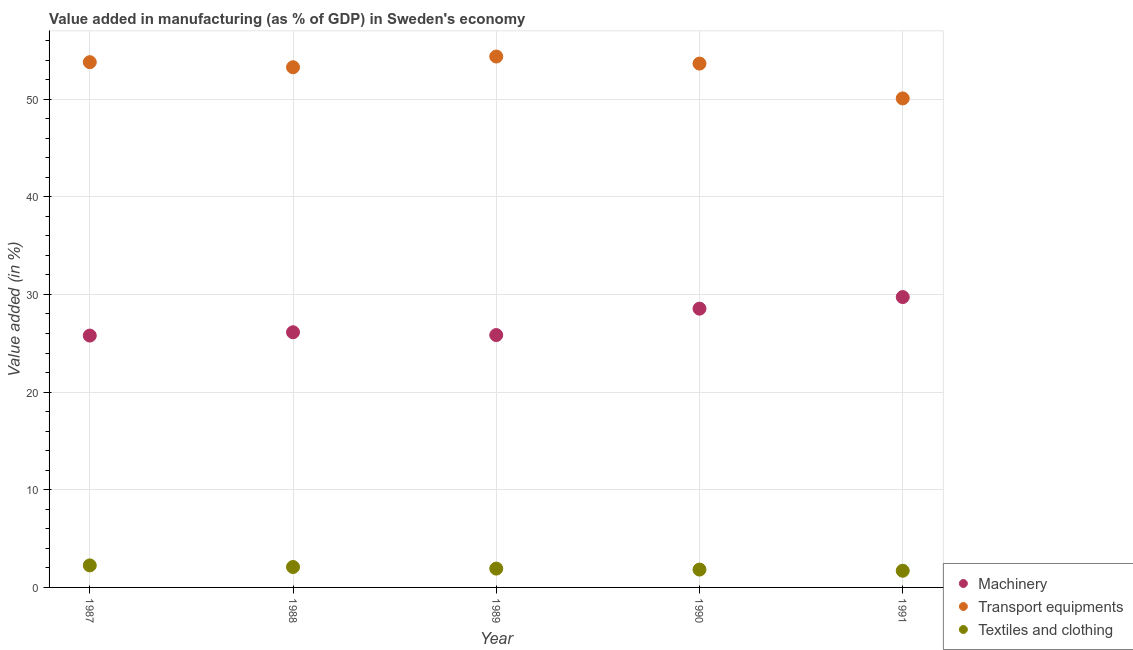What is the value added in manufacturing transport equipments in 1991?
Your answer should be very brief. 50.07. Across all years, what is the maximum value added in manufacturing textile and clothing?
Make the answer very short. 2.26. Across all years, what is the minimum value added in manufacturing transport equipments?
Keep it short and to the point. 50.07. What is the total value added in manufacturing textile and clothing in the graph?
Offer a terse response. 9.81. What is the difference between the value added in manufacturing textile and clothing in 1990 and that in 1991?
Provide a succinct answer. 0.12. What is the difference between the value added in manufacturing transport equipments in 1987 and the value added in manufacturing textile and clothing in 1990?
Provide a succinct answer. 51.95. What is the average value added in manufacturing textile and clothing per year?
Your answer should be compact. 1.96. In the year 1991, what is the difference between the value added in manufacturing transport equipments and value added in manufacturing machinery?
Give a very brief answer. 20.34. In how many years, is the value added in manufacturing machinery greater than 54 %?
Your response must be concise. 0. What is the ratio of the value added in manufacturing textile and clothing in 1987 to that in 1988?
Provide a short and direct response. 1.08. What is the difference between the highest and the second highest value added in manufacturing machinery?
Offer a very short reply. 1.19. What is the difference between the highest and the lowest value added in manufacturing machinery?
Make the answer very short. 3.94. Is the sum of the value added in manufacturing transport equipments in 1988 and 1989 greater than the maximum value added in manufacturing machinery across all years?
Your answer should be compact. Yes. Is it the case that in every year, the sum of the value added in manufacturing machinery and value added in manufacturing transport equipments is greater than the value added in manufacturing textile and clothing?
Give a very brief answer. Yes. Is the value added in manufacturing machinery strictly greater than the value added in manufacturing textile and clothing over the years?
Your response must be concise. Yes. Is the value added in manufacturing machinery strictly less than the value added in manufacturing textile and clothing over the years?
Your answer should be compact. No. Are the values on the major ticks of Y-axis written in scientific E-notation?
Provide a short and direct response. No. Does the graph contain any zero values?
Give a very brief answer. No. How many legend labels are there?
Make the answer very short. 3. How are the legend labels stacked?
Keep it short and to the point. Vertical. What is the title of the graph?
Keep it short and to the point. Value added in manufacturing (as % of GDP) in Sweden's economy. What is the label or title of the Y-axis?
Make the answer very short. Value added (in %). What is the Value added (in %) of Machinery in 1987?
Give a very brief answer. 25.79. What is the Value added (in %) in Transport equipments in 1987?
Your answer should be compact. 53.78. What is the Value added (in %) of Textiles and clothing in 1987?
Your answer should be very brief. 2.26. What is the Value added (in %) of Machinery in 1988?
Keep it short and to the point. 26.13. What is the Value added (in %) of Transport equipments in 1988?
Provide a short and direct response. 53.26. What is the Value added (in %) of Textiles and clothing in 1988?
Your answer should be compact. 2.09. What is the Value added (in %) in Machinery in 1989?
Ensure brevity in your answer.  25.84. What is the Value added (in %) of Transport equipments in 1989?
Give a very brief answer. 54.36. What is the Value added (in %) of Textiles and clothing in 1989?
Make the answer very short. 1.93. What is the Value added (in %) in Machinery in 1990?
Offer a terse response. 28.54. What is the Value added (in %) in Transport equipments in 1990?
Give a very brief answer. 53.64. What is the Value added (in %) of Textiles and clothing in 1990?
Keep it short and to the point. 1.83. What is the Value added (in %) in Machinery in 1991?
Your answer should be very brief. 29.73. What is the Value added (in %) of Transport equipments in 1991?
Make the answer very short. 50.07. What is the Value added (in %) in Textiles and clothing in 1991?
Your answer should be very brief. 1.71. Across all years, what is the maximum Value added (in %) of Machinery?
Offer a very short reply. 29.73. Across all years, what is the maximum Value added (in %) in Transport equipments?
Provide a succinct answer. 54.36. Across all years, what is the maximum Value added (in %) in Textiles and clothing?
Your answer should be compact. 2.26. Across all years, what is the minimum Value added (in %) of Machinery?
Provide a short and direct response. 25.79. Across all years, what is the minimum Value added (in %) of Transport equipments?
Ensure brevity in your answer.  50.07. Across all years, what is the minimum Value added (in %) of Textiles and clothing?
Offer a terse response. 1.71. What is the total Value added (in %) in Machinery in the graph?
Your response must be concise. 136.03. What is the total Value added (in %) of Transport equipments in the graph?
Offer a terse response. 265.12. What is the total Value added (in %) of Textiles and clothing in the graph?
Your response must be concise. 9.81. What is the difference between the Value added (in %) of Machinery in 1987 and that in 1988?
Keep it short and to the point. -0.34. What is the difference between the Value added (in %) of Transport equipments in 1987 and that in 1988?
Keep it short and to the point. 0.52. What is the difference between the Value added (in %) in Textiles and clothing in 1987 and that in 1988?
Offer a terse response. 0.17. What is the difference between the Value added (in %) of Machinery in 1987 and that in 1989?
Your answer should be very brief. -0.05. What is the difference between the Value added (in %) of Transport equipments in 1987 and that in 1989?
Ensure brevity in your answer.  -0.58. What is the difference between the Value added (in %) in Textiles and clothing in 1987 and that in 1989?
Offer a terse response. 0.33. What is the difference between the Value added (in %) of Machinery in 1987 and that in 1990?
Offer a terse response. -2.76. What is the difference between the Value added (in %) in Transport equipments in 1987 and that in 1990?
Ensure brevity in your answer.  0.15. What is the difference between the Value added (in %) of Textiles and clothing in 1987 and that in 1990?
Your response must be concise. 0.43. What is the difference between the Value added (in %) in Machinery in 1987 and that in 1991?
Make the answer very short. -3.94. What is the difference between the Value added (in %) in Transport equipments in 1987 and that in 1991?
Offer a terse response. 3.71. What is the difference between the Value added (in %) of Textiles and clothing in 1987 and that in 1991?
Offer a very short reply. 0.55. What is the difference between the Value added (in %) in Machinery in 1988 and that in 1989?
Your response must be concise. 0.29. What is the difference between the Value added (in %) in Transport equipments in 1988 and that in 1989?
Give a very brief answer. -1.1. What is the difference between the Value added (in %) in Textiles and clothing in 1988 and that in 1989?
Your answer should be very brief. 0.16. What is the difference between the Value added (in %) in Machinery in 1988 and that in 1990?
Give a very brief answer. -2.42. What is the difference between the Value added (in %) in Transport equipments in 1988 and that in 1990?
Offer a terse response. -0.37. What is the difference between the Value added (in %) of Textiles and clothing in 1988 and that in 1990?
Your answer should be very brief. 0.26. What is the difference between the Value added (in %) in Machinery in 1988 and that in 1991?
Your answer should be compact. -3.6. What is the difference between the Value added (in %) of Transport equipments in 1988 and that in 1991?
Your response must be concise. 3.19. What is the difference between the Value added (in %) of Textiles and clothing in 1988 and that in 1991?
Make the answer very short. 0.38. What is the difference between the Value added (in %) in Machinery in 1989 and that in 1990?
Offer a very short reply. -2.7. What is the difference between the Value added (in %) in Transport equipments in 1989 and that in 1990?
Offer a terse response. 0.72. What is the difference between the Value added (in %) in Textiles and clothing in 1989 and that in 1990?
Ensure brevity in your answer.  0.1. What is the difference between the Value added (in %) of Machinery in 1989 and that in 1991?
Give a very brief answer. -3.89. What is the difference between the Value added (in %) in Transport equipments in 1989 and that in 1991?
Your response must be concise. 4.29. What is the difference between the Value added (in %) of Textiles and clothing in 1989 and that in 1991?
Your response must be concise. 0.22. What is the difference between the Value added (in %) of Machinery in 1990 and that in 1991?
Your answer should be compact. -1.19. What is the difference between the Value added (in %) of Transport equipments in 1990 and that in 1991?
Offer a very short reply. 3.57. What is the difference between the Value added (in %) in Textiles and clothing in 1990 and that in 1991?
Ensure brevity in your answer.  0.12. What is the difference between the Value added (in %) in Machinery in 1987 and the Value added (in %) in Transport equipments in 1988?
Your answer should be compact. -27.48. What is the difference between the Value added (in %) in Machinery in 1987 and the Value added (in %) in Textiles and clothing in 1988?
Provide a succinct answer. 23.7. What is the difference between the Value added (in %) of Transport equipments in 1987 and the Value added (in %) of Textiles and clothing in 1988?
Your response must be concise. 51.69. What is the difference between the Value added (in %) of Machinery in 1987 and the Value added (in %) of Transport equipments in 1989?
Give a very brief answer. -28.57. What is the difference between the Value added (in %) of Machinery in 1987 and the Value added (in %) of Textiles and clothing in 1989?
Your answer should be very brief. 23.86. What is the difference between the Value added (in %) of Transport equipments in 1987 and the Value added (in %) of Textiles and clothing in 1989?
Your response must be concise. 51.85. What is the difference between the Value added (in %) in Machinery in 1987 and the Value added (in %) in Transport equipments in 1990?
Your answer should be compact. -27.85. What is the difference between the Value added (in %) in Machinery in 1987 and the Value added (in %) in Textiles and clothing in 1990?
Your response must be concise. 23.96. What is the difference between the Value added (in %) in Transport equipments in 1987 and the Value added (in %) in Textiles and clothing in 1990?
Your response must be concise. 51.95. What is the difference between the Value added (in %) in Machinery in 1987 and the Value added (in %) in Transport equipments in 1991?
Provide a succinct answer. -24.28. What is the difference between the Value added (in %) in Machinery in 1987 and the Value added (in %) in Textiles and clothing in 1991?
Make the answer very short. 24.08. What is the difference between the Value added (in %) of Transport equipments in 1987 and the Value added (in %) of Textiles and clothing in 1991?
Give a very brief answer. 52.08. What is the difference between the Value added (in %) of Machinery in 1988 and the Value added (in %) of Transport equipments in 1989?
Offer a very short reply. -28.23. What is the difference between the Value added (in %) of Machinery in 1988 and the Value added (in %) of Textiles and clothing in 1989?
Your response must be concise. 24.2. What is the difference between the Value added (in %) of Transport equipments in 1988 and the Value added (in %) of Textiles and clothing in 1989?
Provide a succinct answer. 51.34. What is the difference between the Value added (in %) in Machinery in 1988 and the Value added (in %) in Transport equipments in 1990?
Your answer should be compact. -27.51. What is the difference between the Value added (in %) in Machinery in 1988 and the Value added (in %) in Textiles and clothing in 1990?
Keep it short and to the point. 24.3. What is the difference between the Value added (in %) in Transport equipments in 1988 and the Value added (in %) in Textiles and clothing in 1990?
Make the answer very short. 51.43. What is the difference between the Value added (in %) in Machinery in 1988 and the Value added (in %) in Transport equipments in 1991?
Offer a terse response. -23.94. What is the difference between the Value added (in %) in Machinery in 1988 and the Value added (in %) in Textiles and clothing in 1991?
Ensure brevity in your answer.  24.42. What is the difference between the Value added (in %) in Transport equipments in 1988 and the Value added (in %) in Textiles and clothing in 1991?
Provide a succinct answer. 51.56. What is the difference between the Value added (in %) in Machinery in 1989 and the Value added (in %) in Transport equipments in 1990?
Your answer should be compact. -27.8. What is the difference between the Value added (in %) of Machinery in 1989 and the Value added (in %) of Textiles and clothing in 1990?
Offer a terse response. 24.01. What is the difference between the Value added (in %) in Transport equipments in 1989 and the Value added (in %) in Textiles and clothing in 1990?
Ensure brevity in your answer.  52.53. What is the difference between the Value added (in %) in Machinery in 1989 and the Value added (in %) in Transport equipments in 1991?
Give a very brief answer. -24.23. What is the difference between the Value added (in %) of Machinery in 1989 and the Value added (in %) of Textiles and clothing in 1991?
Provide a succinct answer. 24.13. What is the difference between the Value added (in %) of Transport equipments in 1989 and the Value added (in %) of Textiles and clothing in 1991?
Ensure brevity in your answer.  52.65. What is the difference between the Value added (in %) of Machinery in 1990 and the Value added (in %) of Transport equipments in 1991?
Offer a very short reply. -21.53. What is the difference between the Value added (in %) in Machinery in 1990 and the Value added (in %) in Textiles and clothing in 1991?
Provide a short and direct response. 26.84. What is the difference between the Value added (in %) in Transport equipments in 1990 and the Value added (in %) in Textiles and clothing in 1991?
Give a very brief answer. 51.93. What is the average Value added (in %) of Machinery per year?
Provide a succinct answer. 27.21. What is the average Value added (in %) of Transport equipments per year?
Ensure brevity in your answer.  53.02. What is the average Value added (in %) in Textiles and clothing per year?
Provide a short and direct response. 1.96. In the year 1987, what is the difference between the Value added (in %) in Machinery and Value added (in %) in Transport equipments?
Ensure brevity in your answer.  -28. In the year 1987, what is the difference between the Value added (in %) of Machinery and Value added (in %) of Textiles and clothing?
Offer a terse response. 23.53. In the year 1987, what is the difference between the Value added (in %) in Transport equipments and Value added (in %) in Textiles and clothing?
Keep it short and to the point. 51.53. In the year 1988, what is the difference between the Value added (in %) of Machinery and Value added (in %) of Transport equipments?
Keep it short and to the point. -27.14. In the year 1988, what is the difference between the Value added (in %) in Machinery and Value added (in %) in Textiles and clothing?
Give a very brief answer. 24.04. In the year 1988, what is the difference between the Value added (in %) in Transport equipments and Value added (in %) in Textiles and clothing?
Give a very brief answer. 51.17. In the year 1989, what is the difference between the Value added (in %) of Machinery and Value added (in %) of Transport equipments?
Provide a short and direct response. -28.52. In the year 1989, what is the difference between the Value added (in %) of Machinery and Value added (in %) of Textiles and clothing?
Your response must be concise. 23.91. In the year 1989, what is the difference between the Value added (in %) in Transport equipments and Value added (in %) in Textiles and clothing?
Provide a succinct answer. 52.43. In the year 1990, what is the difference between the Value added (in %) of Machinery and Value added (in %) of Transport equipments?
Your answer should be compact. -25.09. In the year 1990, what is the difference between the Value added (in %) in Machinery and Value added (in %) in Textiles and clothing?
Give a very brief answer. 26.72. In the year 1990, what is the difference between the Value added (in %) in Transport equipments and Value added (in %) in Textiles and clothing?
Keep it short and to the point. 51.81. In the year 1991, what is the difference between the Value added (in %) of Machinery and Value added (in %) of Transport equipments?
Provide a succinct answer. -20.34. In the year 1991, what is the difference between the Value added (in %) in Machinery and Value added (in %) in Textiles and clothing?
Make the answer very short. 28.02. In the year 1991, what is the difference between the Value added (in %) of Transport equipments and Value added (in %) of Textiles and clothing?
Ensure brevity in your answer.  48.36. What is the ratio of the Value added (in %) of Transport equipments in 1987 to that in 1988?
Provide a succinct answer. 1.01. What is the ratio of the Value added (in %) of Textiles and clothing in 1987 to that in 1988?
Your response must be concise. 1.08. What is the ratio of the Value added (in %) in Machinery in 1987 to that in 1989?
Offer a very short reply. 1. What is the ratio of the Value added (in %) of Transport equipments in 1987 to that in 1989?
Provide a short and direct response. 0.99. What is the ratio of the Value added (in %) of Textiles and clothing in 1987 to that in 1989?
Keep it short and to the point. 1.17. What is the ratio of the Value added (in %) in Machinery in 1987 to that in 1990?
Provide a short and direct response. 0.9. What is the ratio of the Value added (in %) of Textiles and clothing in 1987 to that in 1990?
Keep it short and to the point. 1.23. What is the ratio of the Value added (in %) of Machinery in 1987 to that in 1991?
Keep it short and to the point. 0.87. What is the ratio of the Value added (in %) in Transport equipments in 1987 to that in 1991?
Keep it short and to the point. 1.07. What is the ratio of the Value added (in %) in Textiles and clothing in 1987 to that in 1991?
Your answer should be very brief. 1.32. What is the ratio of the Value added (in %) of Machinery in 1988 to that in 1989?
Offer a terse response. 1.01. What is the ratio of the Value added (in %) in Transport equipments in 1988 to that in 1989?
Your response must be concise. 0.98. What is the ratio of the Value added (in %) of Textiles and clothing in 1988 to that in 1989?
Offer a very short reply. 1.08. What is the ratio of the Value added (in %) of Machinery in 1988 to that in 1990?
Provide a succinct answer. 0.92. What is the ratio of the Value added (in %) in Transport equipments in 1988 to that in 1990?
Offer a very short reply. 0.99. What is the ratio of the Value added (in %) of Textiles and clothing in 1988 to that in 1990?
Give a very brief answer. 1.14. What is the ratio of the Value added (in %) of Machinery in 1988 to that in 1991?
Your answer should be compact. 0.88. What is the ratio of the Value added (in %) in Transport equipments in 1988 to that in 1991?
Make the answer very short. 1.06. What is the ratio of the Value added (in %) in Textiles and clothing in 1988 to that in 1991?
Make the answer very short. 1.22. What is the ratio of the Value added (in %) in Machinery in 1989 to that in 1990?
Provide a succinct answer. 0.91. What is the ratio of the Value added (in %) in Transport equipments in 1989 to that in 1990?
Offer a very short reply. 1.01. What is the ratio of the Value added (in %) of Textiles and clothing in 1989 to that in 1990?
Provide a succinct answer. 1.05. What is the ratio of the Value added (in %) in Machinery in 1989 to that in 1991?
Your answer should be compact. 0.87. What is the ratio of the Value added (in %) of Transport equipments in 1989 to that in 1991?
Make the answer very short. 1.09. What is the ratio of the Value added (in %) in Textiles and clothing in 1989 to that in 1991?
Offer a very short reply. 1.13. What is the ratio of the Value added (in %) of Machinery in 1990 to that in 1991?
Ensure brevity in your answer.  0.96. What is the ratio of the Value added (in %) of Transport equipments in 1990 to that in 1991?
Your answer should be compact. 1.07. What is the ratio of the Value added (in %) of Textiles and clothing in 1990 to that in 1991?
Make the answer very short. 1.07. What is the difference between the highest and the second highest Value added (in %) in Machinery?
Offer a very short reply. 1.19. What is the difference between the highest and the second highest Value added (in %) in Transport equipments?
Your answer should be very brief. 0.58. What is the difference between the highest and the second highest Value added (in %) in Textiles and clothing?
Offer a terse response. 0.17. What is the difference between the highest and the lowest Value added (in %) in Machinery?
Your response must be concise. 3.94. What is the difference between the highest and the lowest Value added (in %) of Transport equipments?
Your answer should be very brief. 4.29. What is the difference between the highest and the lowest Value added (in %) in Textiles and clothing?
Provide a short and direct response. 0.55. 